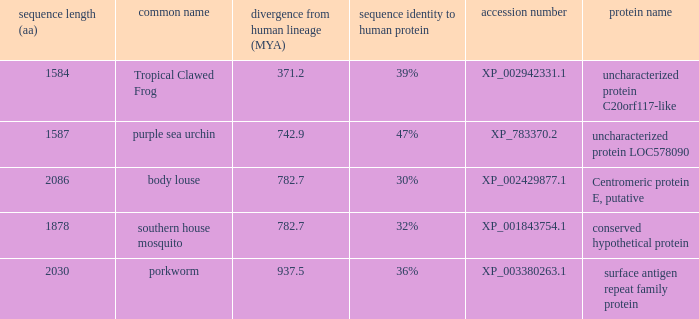What is the protein name of the protein with a sequence identity to human protein of 32%? Conserved hypothetical protein. 